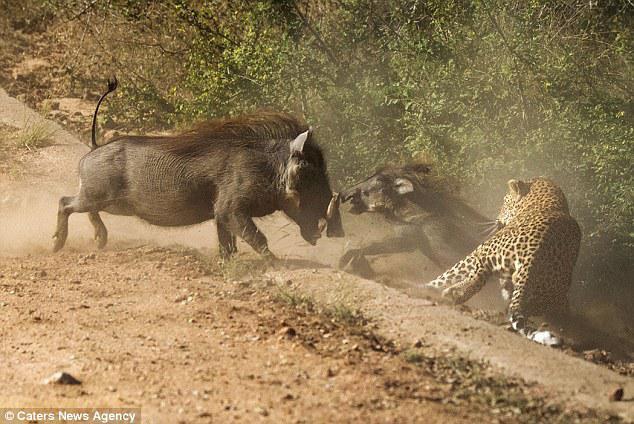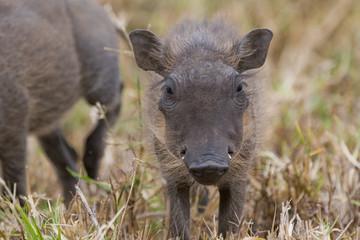The first image is the image on the left, the second image is the image on the right. Assess this claim about the two images: "An image includes a wild cat and a warthog, and the action scene features kicked-up dust.". Correct or not? Answer yes or no. Yes. The first image is the image on the left, the second image is the image on the right. Examine the images to the left and right. Is the description "The right image contains one adult warthog that is standing beside two baby warthogs." accurate? Answer yes or no. No. 